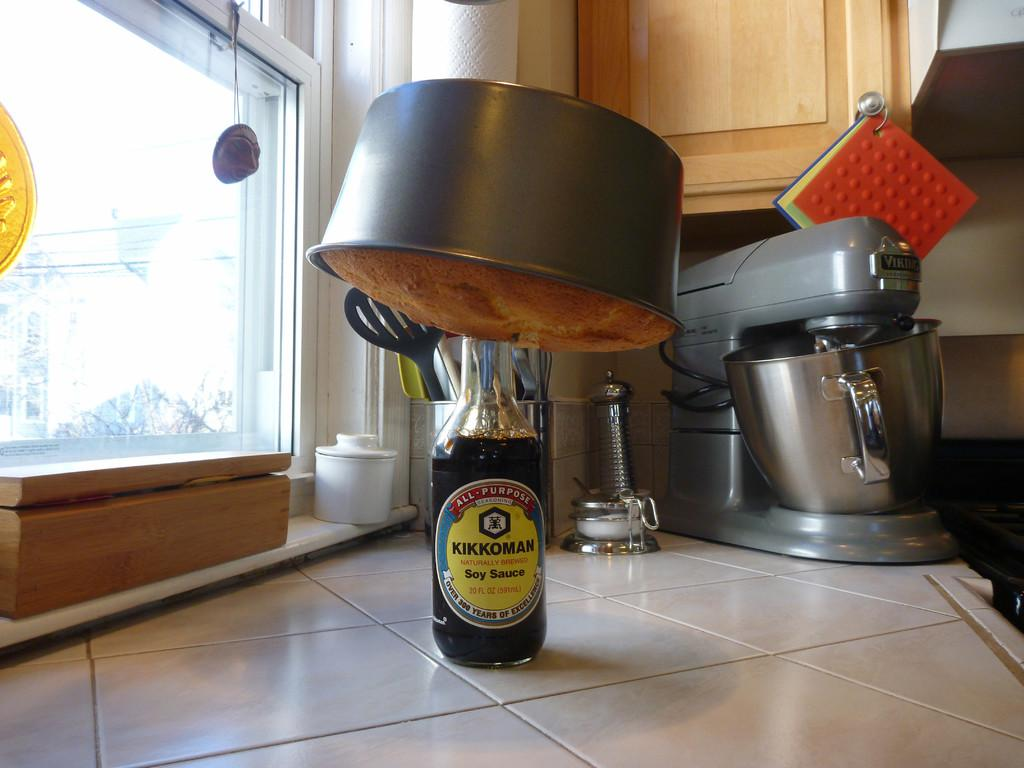<image>
Render a clear and concise summary of the photo. a bottle of soy sauce that is on the table 